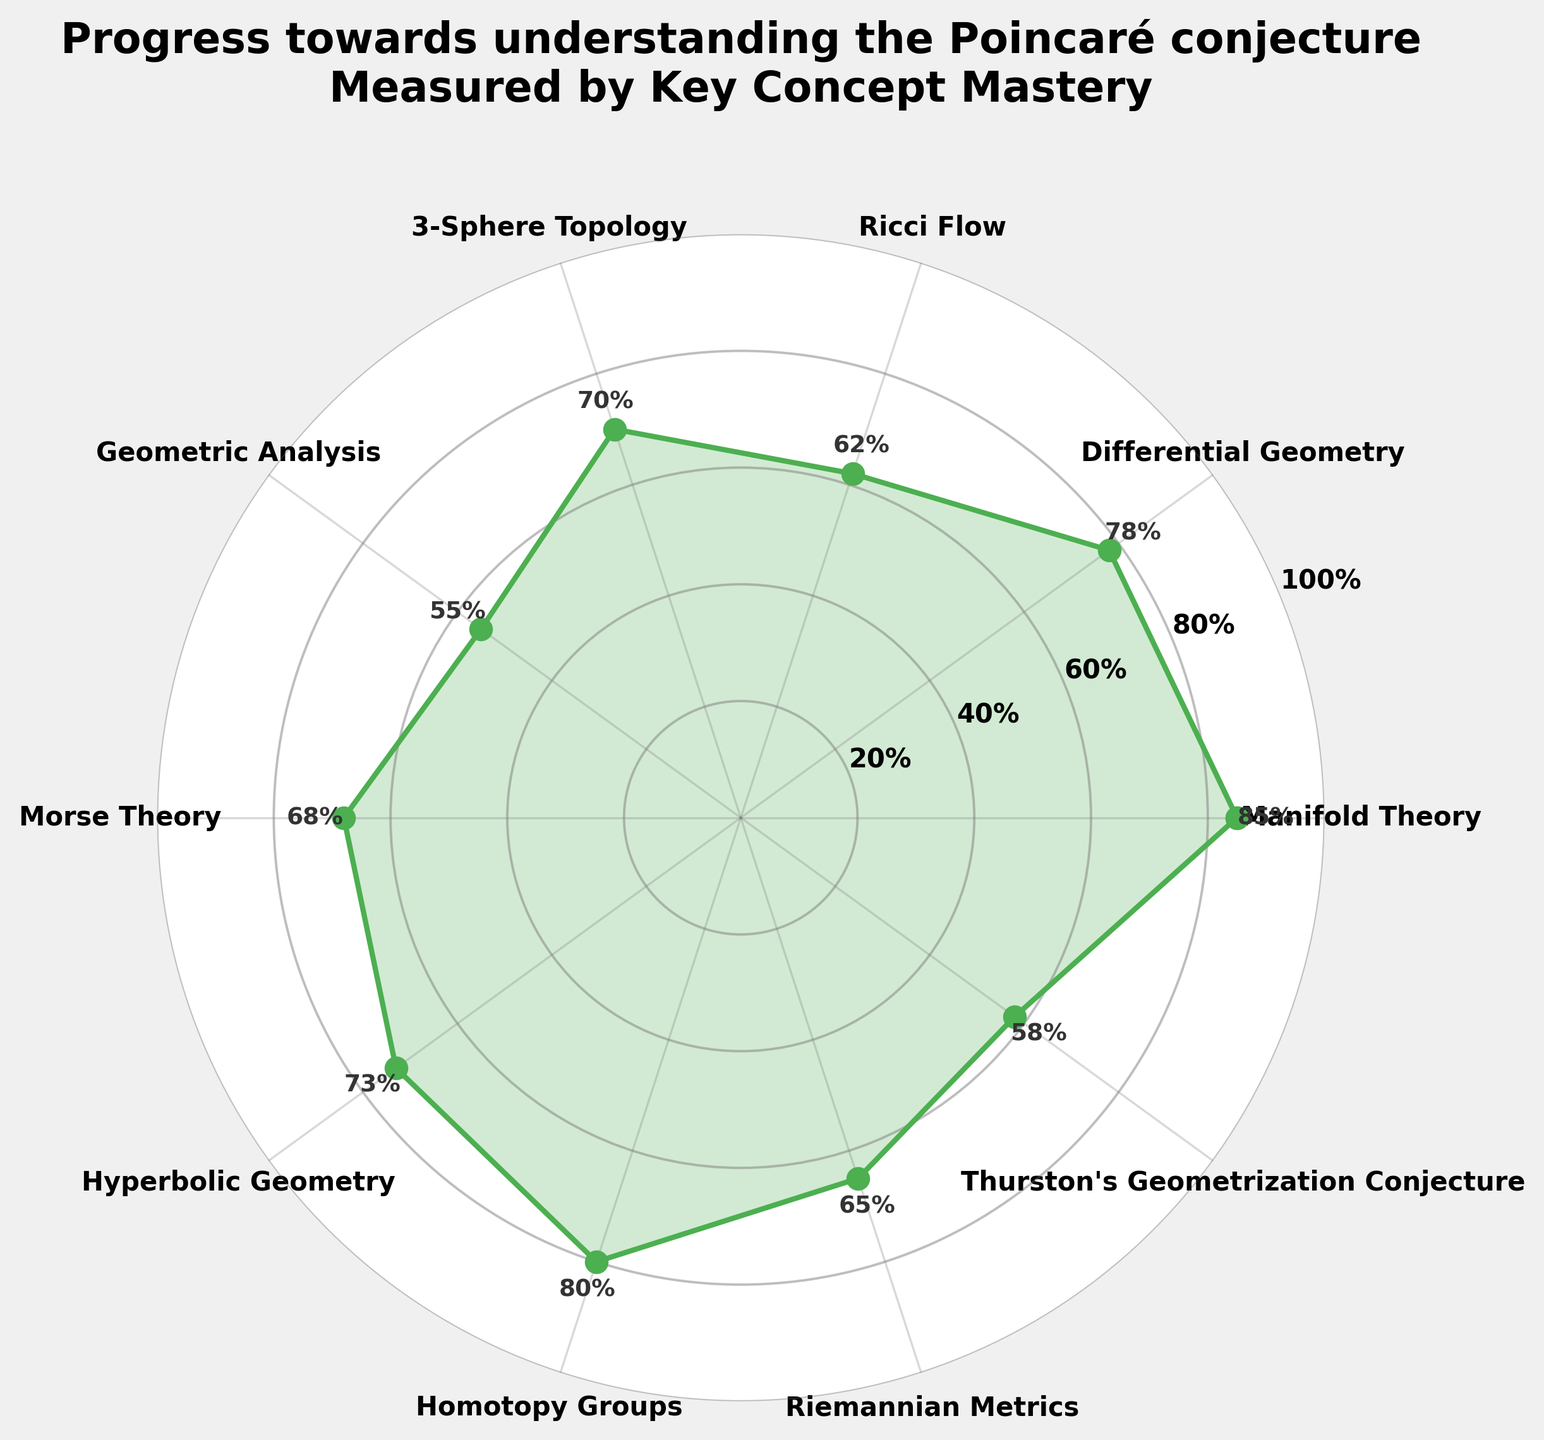What is the highest mastery level indicated in the chart? The highest mastery level indicated is the peak value on the plot, which is represented by the topmost point. By looking at the chart, we identify "Manifold Theory" with a mastery level of 85%.
Answer: 85% How many key concepts are visualized in this chart? Count the distinct labels surrounding the circular chart. Each label represents a key concept. There are 10 key concepts listed in the chart.
Answer: 10 What color is used to fill the area under the mastery levels line? Observing the chart, the area under the mastery levels line is filled with a green color.
Answer: Green What is the median mastery level of the key concepts? To find the median, we first list the mastery levels in ascending order: 55, 58, 62, 65, 68, 70, 73, 78, 80, 85. There are 10 values, so the median is the average of the 5th and 6th values (68 and 70). Thus, (68 + 70) / 2 = 69.
Answer: 69 What is the average mastery level across all key concepts? Add all the mastery levels: 85 + 78 + 62 + 70 + 55 + 68 + 73 + 80 + 65 + 58 = 694. Then, divide by the number of key concepts (10): 694 / 10 = 69.4.
Answer: 69.4 Which key concept has a higher mastery level, "Homotopy Groups" or "Thurston's Geometrization Conjecture"? Compare the mastery levels for "Homotopy Groups" (80%) and "Thurston's Geometrization Conjecture" (58%). "Homotopy Groups" has a higher mastery level.
Answer: Homotopy Groups Which concept is mastered more, "Ricci Flow" or "Riemannian Metrics"? The mastery levels for "Ricci Flow" and "Riemannian Metrics" are 62% and 65%, respectively. "Riemannian Metrics" has a higher mastery level.
Answer: Riemannian Metrics What are the two concepts with the lowest mastery levels? Identify the lowest points on the chart, which correspond to the lowest mastery levels. The concepts "Geometric Analysis" (55%) and "Thurston's Geometrization Conjecture" (58%) are the two lowest.
Answer: Geometric Analysis, Thurston's Geometrization Conjecture Which area of study shows a mastery level nearest to 75%? Look for concepts with mastery levels close to 75%. "Hyperbolic Geometry" with a mastery level of 73% is closest to 75%.
Answer: Hyperbolic Geometry Which concept lies exactly opposite to "Manifold Theory" on the circular chart? Identify the position directly across from "Manifold Theory" which is at the top. The concept directly opposite would be at the bottom, identified as "Riemannian Metrics" (65%).
Answer: Riemannian Metrics 